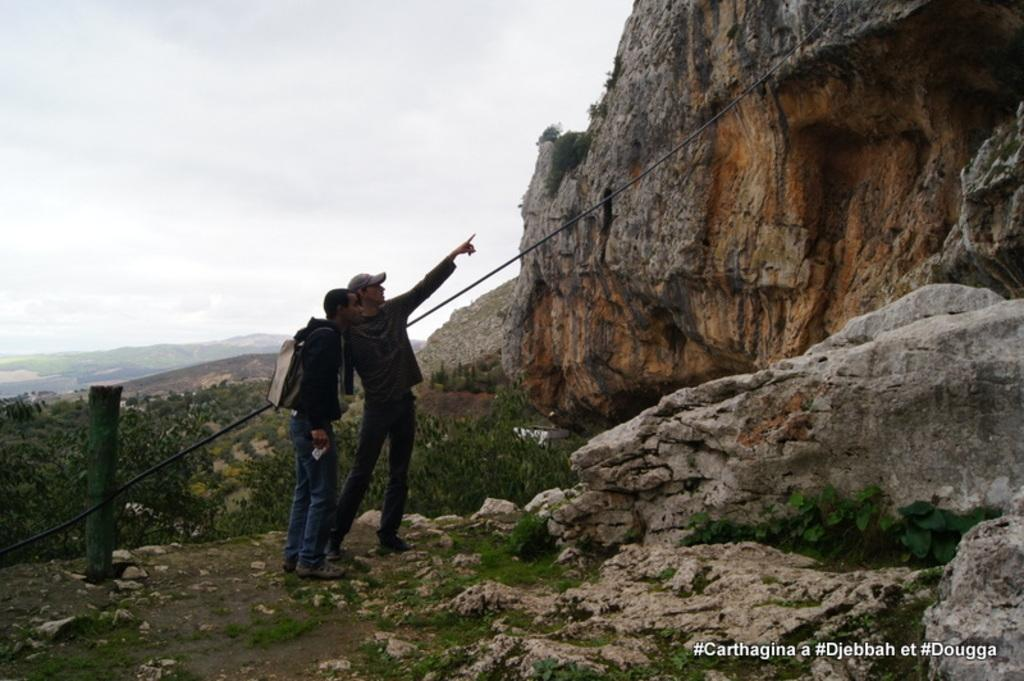How many people are in the image? There are two persons in the image. What are the persons wearing? The persons are wearing black dress. What can be seen on the right side of the image? There is something that resembles a mountain on the right side of the image. What is visible at the top of the image? The sky is visible at the top of the image. What type of disease is affecting the persons in the image? There is no indication of any disease affecting the persons in the image. What time of day is it in the image, considering it's morning? The provided facts do not mention the time of day, so we cannot determine if it's morning or not. 